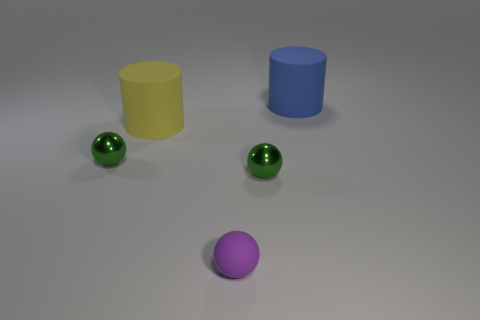What is the size of the rubber cylinder left of the big rubber cylinder that is behind the yellow matte thing?
Give a very brief answer. Large. Are there an equal number of big blue things that are left of the big yellow matte cylinder and matte things in front of the blue cylinder?
Provide a short and direct response. No. What is the color of the other object that is the same shape as the yellow rubber object?
Provide a succinct answer. Blue. There is a small metal object left of the purple thing; is it the same shape as the tiny matte object?
Give a very brief answer. Yes. What shape is the large rubber object to the right of the green metal object that is right of the green thing that is to the left of the tiny purple matte object?
Your answer should be very brief. Cylinder. What size is the purple matte object?
Provide a short and direct response. Small. What is the color of the large cylinder that is the same material as the large yellow thing?
Keep it short and to the point. Blue. What number of tiny purple spheres have the same material as the purple object?
Provide a short and direct response. 0. There is a small rubber sphere; does it have the same color as the large thing behind the large yellow cylinder?
Provide a succinct answer. No. The sphere that is left of the cylinder that is left of the small purple thing is what color?
Provide a succinct answer. Green. 